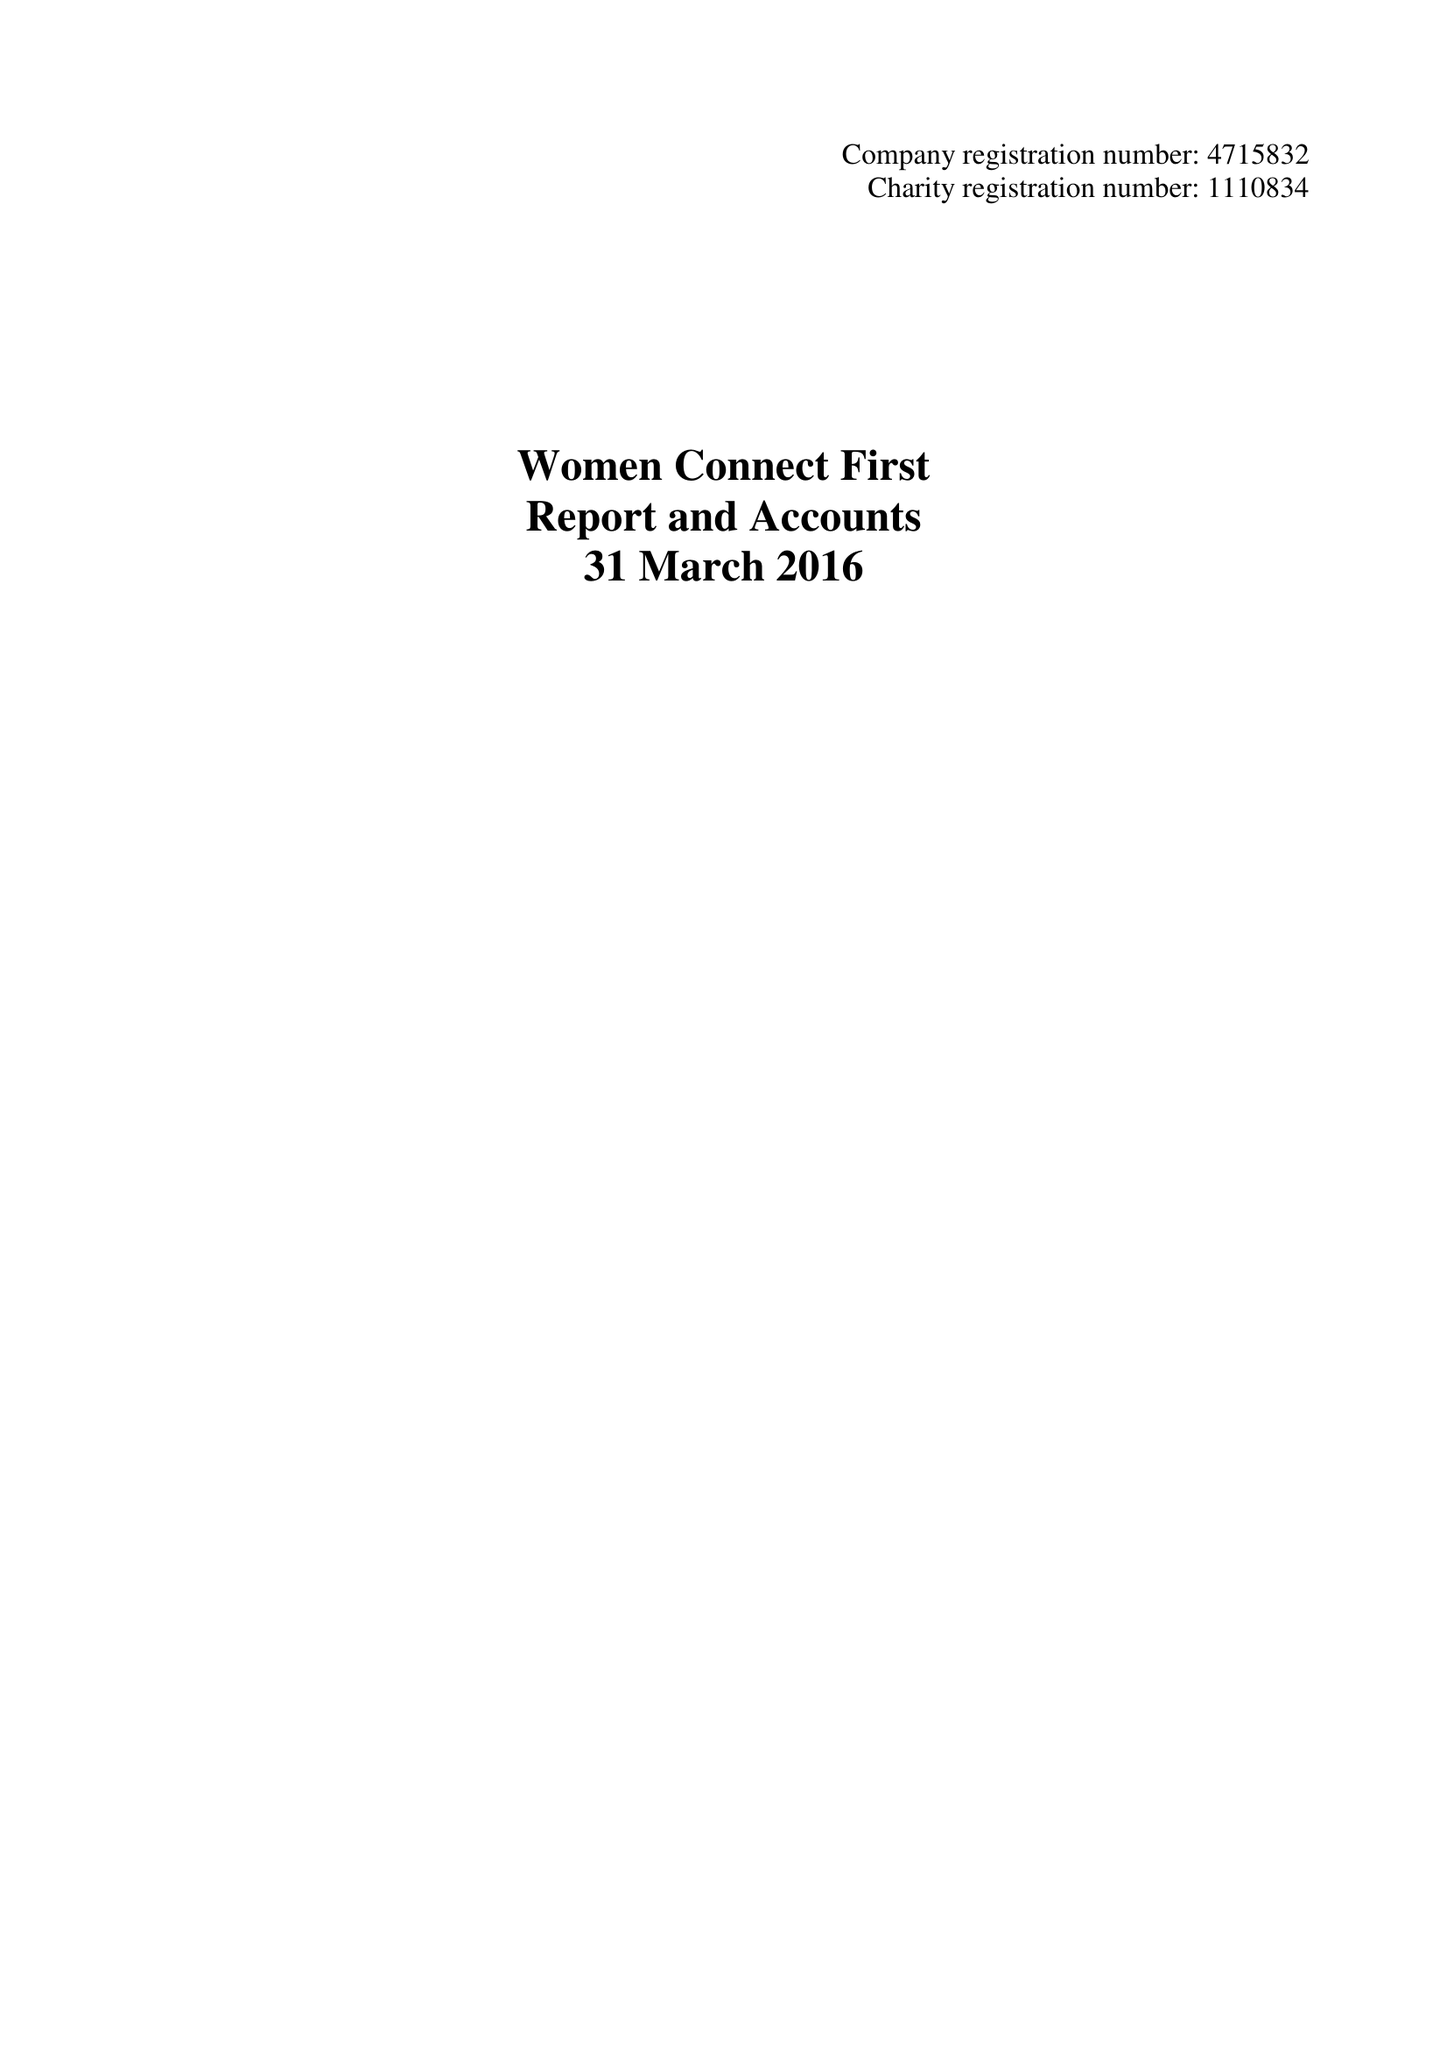What is the value for the address__postcode?
Answer the question using a single word or phrase. CF11 6LP 